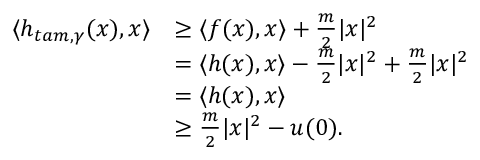Convert formula to latex. <formula><loc_0><loc_0><loc_500><loc_500>\begin{array} { r l } { \langle h _ { t a m , \gamma } ( x ) , x \rangle } & { \geq \langle f ( x ) , x \rangle + \frac { m } { 2 } | x | ^ { 2 } } \\ & { = \langle h ( x ) , x \rangle - \frac { m } { 2 } | x | ^ { 2 } + \frac { m } { 2 } | x | ^ { 2 } } \\ & { = \langle h ( x ) , x \rangle } \\ & { \geq \frac { m } { 2 } | x | ^ { 2 } - u ( 0 ) . } \end{array}</formula> 